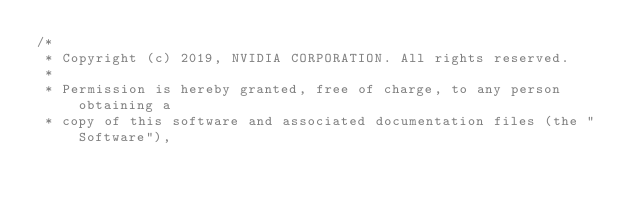<code> <loc_0><loc_0><loc_500><loc_500><_Cuda_>/*
 * Copyright (c) 2019, NVIDIA CORPORATION. All rights reserved.
 *
 * Permission is hereby granted, free of charge, to any person obtaining a
 * copy of this software and associated documentation files (the "Software"),</code> 